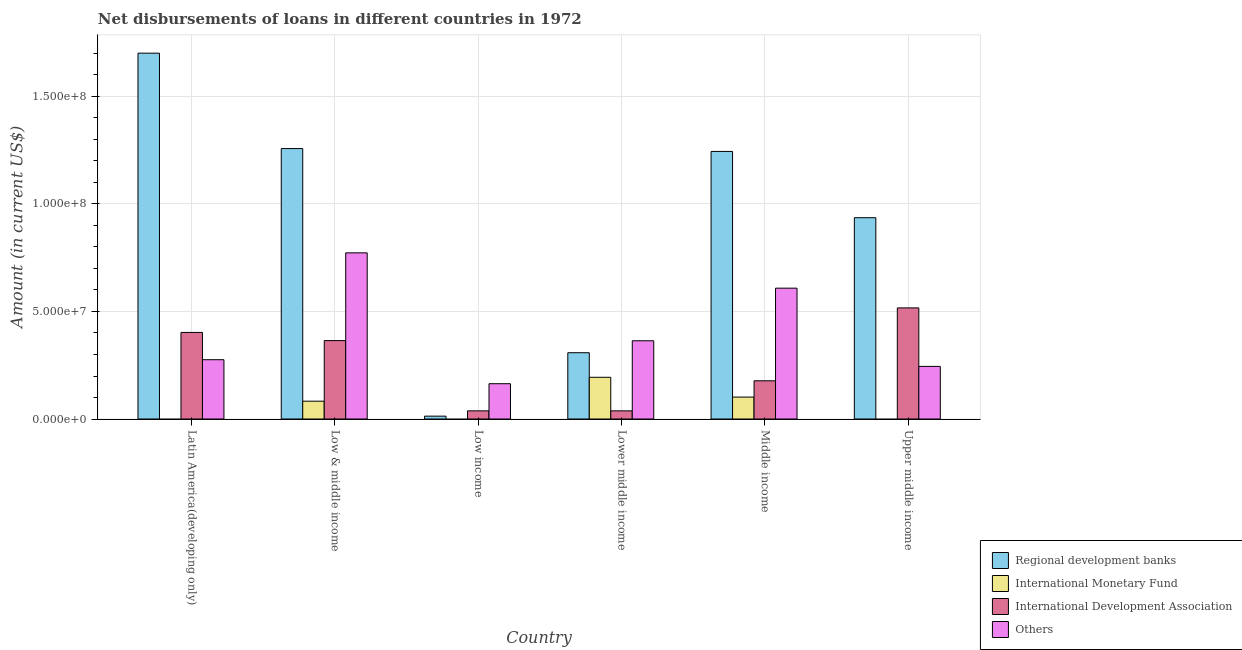How many groups of bars are there?
Provide a short and direct response. 6. Are the number of bars on each tick of the X-axis equal?
Your answer should be very brief. No. How many bars are there on the 6th tick from the left?
Keep it short and to the point. 3. How many bars are there on the 2nd tick from the right?
Provide a succinct answer. 4. What is the label of the 1st group of bars from the left?
Your answer should be compact. Latin America(developing only). In how many cases, is the number of bars for a given country not equal to the number of legend labels?
Make the answer very short. 3. What is the amount of loan disimbursed by regional development banks in Low income?
Provide a short and direct response. 1.33e+06. Across all countries, what is the maximum amount of loan disimbursed by other organisations?
Your answer should be compact. 7.73e+07. Across all countries, what is the minimum amount of loan disimbursed by international development association?
Your answer should be very brief. 3.80e+06. In which country was the amount of loan disimbursed by regional development banks maximum?
Provide a succinct answer. Latin America(developing only). What is the total amount of loan disimbursed by international development association in the graph?
Your answer should be very brief. 1.54e+08. What is the difference between the amount of loan disimbursed by regional development banks in Low & middle income and that in Low income?
Your answer should be compact. 1.24e+08. What is the difference between the amount of loan disimbursed by international monetary fund in Upper middle income and the amount of loan disimbursed by other organisations in Low & middle income?
Give a very brief answer. -7.73e+07. What is the average amount of loan disimbursed by other organisations per country?
Your answer should be very brief. 4.05e+07. What is the difference between the amount of loan disimbursed by international monetary fund and amount of loan disimbursed by regional development banks in Middle income?
Provide a succinct answer. -1.14e+08. Is the amount of loan disimbursed by other organisations in Low & middle income less than that in Middle income?
Your answer should be compact. No. Is the difference between the amount of loan disimbursed by other organisations in Low & middle income and Lower middle income greater than the difference between the amount of loan disimbursed by regional development banks in Low & middle income and Lower middle income?
Ensure brevity in your answer.  No. What is the difference between the highest and the second highest amount of loan disimbursed by regional development banks?
Make the answer very short. 4.44e+07. What is the difference between the highest and the lowest amount of loan disimbursed by other organisations?
Make the answer very short. 6.09e+07. In how many countries, is the amount of loan disimbursed by international monetary fund greater than the average amount of loan disimbursed by international monetary fund taken over all countries?
Provide a short and direct response. 3. Is it the case that in every country, the sum of the amount of loan disimbursed by regional development banks and amount of loan disimbursed by international monetary fund is greater than the amount of loan disimbursed by international development association?
Offer a terse response. No. What is the difference between two consecutive major ticks on the Y-axis?
Provide a short and direct response. 5.00e+07. Are the values on the major ticks of Y-axis written in scientific E-notation?
Provide a succinct answer. Yes. Does the graph contain grids?
Offer a terse response. Yes. Where does the legend appear in the graph?
Offer a very short reply. Bottom right. How many legend labels are there?
Make the answer very short. 4. How are the legend labels stacked?
Give a very brief answer. Vertical. What is the title of the graph?
Offer a terse response. Net disbursements of loans in different countries in 1972. Does "Quality Certification" appear as one of the legend labels in the graph?
Keep it short and to the point. No. What is the label or title of the Y-axis?
Your answer should be very brief. Amount (in current US$). What is the Amount (in current US$) in Regional development banks in Latin America(developing only)?
Offer a very short reply. 1.70e+08. What is the Amount (in current US$) of International Development Association in Latin America(developing only)?
Provide a short and direct response. 4.03e+07. What is the Amount (in current US$) of Others in Latin America(developing only)?
Keep it short and to the point. 2.76e+07. What is the Amount (in current US$) of Regional development banks in Low & middle income?
Ensure brevity in your answer.  1.26e+08. What is the Amount (in current US$) in International Monetary Fund in Low & middle income?
Give a very brief answer. 8.30e+06. What is the Amount (in current US$) of International Development Association in Low & middle income?
Your answer should be very brief. 3.65e+07. What is the Amount (in current US$) of Others in Low & middle income?
Give a very brief answer. 7.73e+07. What is the Amount (in current US$) of Regional development banks in Low income?
Offer a terse response. 1.33e+06. What is the Amount (in current US$) of International Monetary Fund in Low income?
Provide a short and direct response. 0. What is the Amount (in current US$) of International Development Association in Low income?
Provide a succinct answer. 3.80e+06. What is the Amount (in current US$) in Others in Low income?
Provide a short and direct response. 1.64e+07. What is the Amount (in current US$) of Regional development banks in Lower middle income?
Provide a short and direct response. 3.08e+07. What is the Amount (in current US$) of International Monetary Fund in Lower middle income?
Offer a very short reply. 1.94e+07. What is the Amount (in current US$) of International Development Association in Lower middle income?
Offer a terse response. 3.80e+06. What is the Amount (in current US$) of Others in Lower middle income?
Make the answer very short. 3.64e+07. What is the Amount (in current US$) in Regional development banks in Middle income?
Make the answer very short. 1.24e+08. What is the Amount (in current US$) in International Monetary Fund in Middle income?
Offer a terse response. 1.02e+07. What is the Amount (in current US$) of International Development Association in Middle income?
Your answer should be very brief. 1.78e+07. What is the Amount (in current US$) in Others in Middle income?
Provide a short and direct response. 6.09e+07. What is the Amount (in current US$) in Regional development banks in Upper middle income?
Your answer should be very brief. 9.36e+07. What is the Amount (in current US$) of International Monetary Fund in Upper middle income?
Offer a very short reply. 0. What is the Amount (in current US$) of International Development Association in Upper middle income?
Ensure brevity in your answer.  5.17e+07. What is the Amount (in current US$) in Others in Upper middle income?
Your response must be concise. 2.45e+07. Across all countries, what is the maximum Amount (in current US$) of Regional development banks?
Your response must be concise. 1.70e+08. Across all countries, what is the maximum Amount (in current US$) of International Monetary Fund?
Your response must be concise. 1.94e+07. Across all countries, what is the maximum Amount (in current US$) in International Development Association?
Offer a terse response. 5.17e+07. Across all countries, what is the maximum Amount (in current US$) of Others?
Provide a succinct answer. 7.73e+07. Across all countries, what is the minimum Amount (in current US$) in Regional development banks?
Offer a very short reply. 1.33e+06. Across all countries, what is the minimum Amount (in current US$) in International Monetary Fund?
Offer a terse response. 0. Across all countries, what is the minimum Amount (in current US$) of International Development Association?
Offer a terse response. 3.80e+06. Across all countries, what is the minimum Amount (in current US$) of Others?
Ensure brevity in your answer.  1.64e+07. What is the total Amount (in current US$) of Regional development banks in the graph?
Give a very brief answer. 5.46e+08. What is the total Amount (in current US$) of International Monetary Fund in the graph?
Make the answer very short. 3.79e+07. What is the total Amount (in current US$) of International Development Association in the graph?
Offer a terse response. 1.54e+08. What is the total Amount (in current US$) of Others in the graph?
Provide a short and direct response. 2.43e+08. What is the difference between the Amount (in current US$) in Regional development banks in Latin America(developing only) and that in Low & middle income?
Your response must be concise. 4.44e+07. What is the difference between the Amount (in current US$) in International Development Association in Latin America(developing only) and that in Low & middle income?
Offer a terse response. 3.80e+06. What is the difference between the Amount (in current US$) in Others in Latin America(developing only) and that in Low & middle income?
Keep it short and to the point. -4.97e+07. What is the difference between the Amount (in current US$) in Regional development banks in Latin America(developing only) and that in Low income?
Give a very brief answer. 1.69e+08. What is the difference between the Amount (in current US$) of International Development Association in Latin America(developing only) and that in Low income?
Offer a very short reply. 3.65e+07. What is the difference between the Amount (in current US$) of Others in Latin America(developing only) and that in Low income?
Keep it short and to the point. 1.12e+07. What is the difference between the Amount (in current US$) of Regional development banks in Latin America(developing only) and that in Lower middle income?
Your answer should be compact. 1.39e+08. What is the difference between the Amount (in current US$) of International Development Association in Latin America(developing only) and that in Lower middle income?
Provide a short and direct response. 3.65e+07. What is the difference between the Amount (in current US$) in Others in Latin America(developing only) and that in Lower middle income?
Ensure brevity in your answer.  -8.81e+06. What is the difference between the Amount (in current US$) of Regional development banks in Latin America(developing only) and that in Middle income?
Your answer should be compact. 4.57e+07. What is the difference between the Amount (in current US$) in International Development Association in Latin America(developing only) and that in Middle income?
Your answer should be very brief. 2.25e+07. What is the difference between the Amount (in current US$) of Others in Latin America(developing only) and that in Middle income?
Your answer should be very brief. -3.33e+07. What is the difference between the Amount (in current US$) in Regional development banks in Latin America(developing only) and that in Upper middle income?
Make the answer very short. 7.65e+07. What is the difference between the Amount (in current US$) in International Development Association in Latin America(developing only) and that in Upper middle income?
Your response must be concise. -1.14e+07. What is the difference between the Amount (in current US$) in Others in Latin America(developing only) and that in Upper middle income?
Provide a short and direct response. 3.11e+06. What is the difference between the Amount (in current US$) in Regional development banks in Low & middle income and that in Low income?
Your response must be concise. 1.24e+08. What is the difference between the Amount (in current US$) in International Development Association in Low & middle income and that in Low income?
Make the answer very short. 3.27e+07. What is the difference between the Amount (in current US$) of Others in Low & middle income and that in Low income?
Your answer should be compact. 6.09e+07. What is the difference between the Amount (in current US$) of Regional development banks in Low & middle income and that in Lower middle income?
Ensure brevity in your answer.  9.49e+07. What is the difference between the Amount (in current US$) of International Monetary Fund in Low & middle income and that in Lower middle income?
Provide a short and direct response. -1.11e+07. What is the difference between the Amount (in current US$) of International Development Association in Low & middle income and that in Lower middle income?
Offer a terse response. 3.27e+07. What is the difference between the Amount (in current US$) in Others in Low & middle income and that in Lower middle income?
Ensure brevity in your answer.  4.09e+07. What is the difference between the Amount (in current US$) in Regional development banks in Low & middle income and that in Middle income?
Ensure brevity in your answer.  1.33e+06. What is the difference between the Amount (in current US$) of International Monetary Fund in Low & middle income and that in Middle income?
Keep it short and to the point. -1.90e+06. What is the difference between the Amount (in current US$) of International Development Association in Low & middle income and that in Middle income?
Your response must be concise. 1.87e+07. What is the difference between the Amount (in current US$) in Others in Low & middle income and that in Middle income?
Your answer should be very brief. 1.64e+07. What is the difference between the Amount (in current US$) in Regional development banks in Low & middle income and that in Upper middle income?
Provide a succinct answer. 3.22e+07. What is the difference between the Amount (in current US$) in International Development Association in Low & middle income and that in Upper middle income?
Offer a terse response. -1.52e+07. What is the difference between the Amount (in current US$) in Others in Low & middle income and that in Upper middle income?
Make the answer very short. 5.28e+07. What is the difference between the Amount (in current US$) of Regional development banks in Low income and that in Lower middle income?
Your answer should be very brief. -2.95e+07. What is the difference between the Amount (in current US$) in International Development Association in Low income and that in Lower middle income?
Provide a succinct answer. 0. What is the difference between the Amount (in current US$) in Others in Low income and that in Lower middle income?
Ensure brevity in your answer.  -2.00e+07. What is the difference between the Amount (in current US$) in Regional development banks in Low income and that in Middle income?
Keep it short and to the point. -1.23e+08. What is the difference between the Amount (in current US$) of International Development Association in Low income and that in Middle income?
Your answer should be very brief. -1.40e+07. What is the difference between the Amount (in current US$) of Others in Low income and that in Middle income?
Your response must be concise. -4.44e+07. What is the difference between the Amount (in current US$) in Regional development banks in Low income and that in Upper middle income?
Offer a very short reply. -9.23e+07. What is the difference between the Amount (in current US$) of International Development Association in Low income and that in Upper middle income?
Offer a very short reply. -4.79e+07. What is the difference between the Amount (in current US$) of Others in Low income and that in Upper middle income?
Offer a very short reply. -8.05e+06. What is the difference between the Amount (in current US$) of Regional development banks in Lower middle income and that in Middle income?
Provide a succinct answer. -9.36e+07. What is the difference between the Amount (in current US$) of International Monetary Fund in Lower middle income and that in Middle income?
Offer a terse response. 9.21e+06. What is the difference between the Amount (in current US$) of International Development Association in Lower middle income and that in Middle income?
Offer a very short reply. -1.40e+07. What is the difference between the Amount (in current US$) of Others in Lower middle income and that in Middle income?
Keep it short and to the point. -2.45e+07. What is the difference between the Amount (in current US$) of Regional development banks in Lower middle income and that in Upper middle income?
Your response must be concise. -6.28e+07. What is the difference between the Amount (in current US$) in International Development Association in Lower middle income and that in Upper middle income?
Provide a short and direct response. -4.79e+07. What is the difference between the Amount (in current US$) in Others in Lower middle income and that in Upper middle income?
Your answer should be very brief. 1.19e+07. What is the difference between the Amount (in current US$) in Regional development banks in Middle income and that in Upper middle income?
Make the answer very short. 3.08e+07. What is the difference between the Amount (in current US$) of International Development Association in Middle income and that in Upper middle income?
Your answer should be very brief. -3.39e+07. What is the difference between the Amount (in current US$) in Others in Middle income and that in Upper middle income?
Provide a succinct answer. 3.64e+07. What is the difference between the Amount (in current US$) of Regional development banks in Latin America(developing only) and the Amount (in current US$) of International Monetary Fund in Low & middle income?
Keep it short and to the point. 1.62e+08. What is the difference between the Amount (in current US$) in Regional development banks in Latin America(developing only) and the Amount (in current US$) in International Development Association in Low & middle income?
Provide a succinct answer. 1.34e+08. What is the difference between the Amount (in current US$) of Regional development banks in Latin America(developing only) and the Amount (in current US$) of Others in Low & middle income?
Offer a terse response. 9.29e+07. What is the difference between the Amount (in current US$) of International Development Association in Latin America(developing only) and the Amount (in current US$) of Others in Low & middle income?
Give a very brief answer. -3.70e+07. What is the difference between the Amount (in current US$) of Regional development banks in Latin America(developing only) and the Amount (in current US$) of International Development Association in Low income?
Provide a succinct answer. 1.66e+08. What is the difference between the Amount (in current US$) in Regional development banks in Latin America(developing only) and the Amount (in current US$) in Others in Low income?
Ensure brevity in your answer.  1.54e+08. What is the difference between the Amount (in current US$) of International Development Association in Latin America(developing only) and the Amount (in current US$) of Others in Low income?
Your response must be concise. 2.38e+07. What is the difference between the Amount (in current US$) of Regional development banks in Latin America(developing only) and the Amount (in current US$) of International Monetary Fund in Lower middle income?
Provide a short and direct response. 1.51e+08. What is the difference between the Amount (in current US$) in Regional development banks in Latin America(developing only) and the Amount (in current US$) in International Development Association in Lower middle income?
Your response must be concise. 1.66e+08. What is the difference between the Amount (in current US$) in Regional development banks in Latin America(developing only) and the Amount (in current US$) in Others in Lower middle income?
Your response must be concise. 1.34e+08. What is the difference between the Amount (in current US$) of International Development Association in Latin America(developing only) and the Amount (in current US$) of Others in Lower middle income?
Your answer should be compact. 3.88e+06. What is the difference between the Amount (in current US$) in Regional development banks in Latin America(developing only) and the Amount (in current US$) in International Monetary Fund in Middle income?
Your answer should be very brief. 1.60e+08. What is the difference between the Amount (in current US$) in Regional development banks in Latin America(developing only) and the Amount (in current US$) in International Development Association in Middle income?
Your answer should be very brief. 1.52e+08. What is the difference between the Amount (in current US$) of Regional development banks in Latin America(developing only) and the Amount (in current US$) of Others in Middle income?
Provide a short and direct response. 1.09e+08. What is the difference between the Amount (in current US$) of International Development Association in Latin America(developing only) and the Amount (in current US$) of Others in Middle income?
Make the answer very short. -2.06e+07. What is the difference between the Amount (in current US$) in Regional development banks in Latin America(developing only) and the Amount (in current US$) in International Development Association in Upper middle income?
Make the answer very short. 1.18e+08. What is the difference between the Amount (in current US$) of Regional development banks in Latin America(developing only) and the Amount (in current US$) of Others in Upper middle income?
Your response must be concise. 1.46e+08. What is the difference between the Amount (in current US$) of International Development Association in Latin America(developing only) and the Amount (in current US$) of Others in Upper middle income?
Ensure brevity in your answer.  1.58e+07. What is the difference between the Amount (in current US$) of Regional development banks in Low & middle income and the Amount (in current US$) of International Development Association in Low income?
Give a very brief answer. 1.22e+08. What is the difference between the Amount (in current US$) in Regional development banks in Low & middle income and the Amount (in current US$) in Others in Low income?
Ensure brevity in your answer.  1.09e+08. What is the difference between the Amount (in current US$) of International Monetary Fund in Low & middle income and the Amount (in current US$) of International Development Association in Low income?
Make the answer very short. 4.50e+06. What is the difference between the Amount (in current US$) of International Monetary Fund in Low & middle income and the Amount (in current US$) of Others in Low income?
Offer a terse response. -8.12e+06. What is the difference between the Amount (in current US$) in International Development Association in Low & middle income and the Amount (in current US$) in Others in Low income?
Provide a short and direct response. 2.00e+07. What is the difference between the Amount (in current US$) in Regional development banks in Low & middle income and the Amount (in current US$) in International Monetary Fund in Lower middle income?
Provide a short and direct response. 1.06e+08. What is the difference between the Amount (in current US$) in Regional development banks in Low & middle income and the Amount (in current US$) in International Development Association in Lower middle income?
Give a very brief answer. 1.22e+08. What is the difference between the Amount (in current US$) in Regional development banks in Low & middle income and the Amount (in current US$) in Others in Lower middle income?
Your answer should be very brief. 8.94e+07. What is the difference between the Amount (in current US$) of International Monetary Fund in Low & middle income and the Amount (in current US$) of International Development Association in Lower middle income?
Provide a succinct answer. 4.50e+06. What is the difference between the Amount (in current US$) of International Monetary Fund in Low & middle income and the Amount (in current US$) of Others in Lower middle income?
Your answer should be compact. -2.81e+07. What is the difference between the Amount (in current US$) in International Development Association in Low & middle income and the Amount (in current US$) in Others in Lower middle income?
Ensure brevity in your answer.  8.30e+04. What is the difference between the Amount (in current US$) of Regional development banks in Low & middle income and the Amount (in current US$) of International Monetary Fund in Middle income?
Give a very brief answer. 1.16e+08. What is the difference between the Amount (in current US$) of Regional development banks in Low & middle income and the Amount (in current US$) of International Development Association in Middle income?
Your answer should be compact. 1.08e+08. What is the difference between the Amount (in current US$) in Regional development banks in Low & middle income and the Amount (in current US$) in Others in Middle income?
Give a very brief answer. 6.49e+07. What is the difference between the Amount (in current US$) of International Monetary Fund in Low & middle income and the Amount (in current US$) of International Development Association in Middle income?
Give a very brief answer. -9.48e+06. What is the difference between the Amount (in current US$) of International Monetary Fund in Low & middle income and the Amount (in current US$) of Others in Middle income?
Keep it short and to the point. -5.26e+07. What is the difference between the Amount (in current US$) of International Development Association in Low & middle income and the Amount (in current US$) of Others in Middle income?
Make the answer very short. -2.44e+07. What is the difference between the Amount (in current US$) in Regional development banks in Low & middle income and the Amount (in current US$) in International Development Association in Upper middle income?
Offer a very short reply. 7.41e+07. What is the difference between the Amount (in current US$) of Regional development banks in Low & middle income and the Amount (in current US$) of Others in Upper middle income?
Offer a very short reply. 1.01e+08. What is the difference between the Amount (in current US$) in International Monetary Fund in Low & middle income and the Amount (in current US$) in International Development Association in Upper middle income?
Provide a succinct answer. -4.34e+07. What is the difference between the Amount (in current US$) of International Monetary Fund in Low & middle income and the Amount (in current US$) of Others in Upper middle income?
Make the answer very short. -1.62e+07. What is the difference between the Amount (in current US$) of Regional development banks in Low income and the Amount (in current US$) of International Monetary Fund in Lower middle income?
Keep it short and to the point. -1.81e+07. What is the difference between the Amount (in current US$) in Regional development banks in Low income and the Amount (in current US$) in International Development Association in Lower middle income?
Ensure brevity in your answer.  -2.46e+06. What is the difference between the Amount (in current US$) of Regional development banks in Low income and the Amount (in current US$) of Others in Lower middle income?
Ensure brevity in your answer.  -3.51e+07. What is the difference between the Amount (in current US$) in International Development Association in Low income and the Amount (in current US$) in Others in Lower middle income?
Your response must be concise. -3.26e+07. What is the difference between the Amount (in current US$) in Regional development banks in Low income and the Amount (in current US$) in International Monetary Fund in Middle income?
Provide a succinct answer. -8.86e+06. What is the difference between the Amount (in current US$) in Regional development banks in Low income and the Amount (in current US$) in International Development Association in Middle income?
Your answer should be very brief. -1.64e+07. What is the difference between the Amount (in current US$) in Regional development banks in Low income and the Amount (in current US$) in Others in Middle income?
Your answer should be very brief. -5.95e+07. What is the difference between the Amount (in current US$) in International Development Association in Low income and the Amount (in current US$) in Others in Middle income?
Offer a very short reply. -5.71e+07. What is the difference between the Amount (in current US$) in Regional development banks in Low income and the Amount (in current US$) in International Development Association in Upper middle income?
Ensure brevity in your answer.  -5.03e+07. What is the difference between the Amount (in current US$) of Regional development banks in Low income and the Amount (in current US$) of Others in Upper middle income?
Your answer should be compact. -2.31e+07. What is the difference between the Amount (in current US$) of International Development Association in Low income and the Amount (in current US$) of Others in Upper middle income?
Your answer should be very brief. -2.07e+07. What is the difference between the Amount (in current US$) in Regional development banks in Lower middle income and the Amount (in current US$) in International Monetary Fund in Middle income?
Provide a succinct answer. 2.06e+07. What is the difference between the Amount (in current US$) in Regional development banks in Lower middle income and the Amount (in current US$) in International Development Association in Middle income?
Offer a very short reply. 1.30e+07. What is the difference between the Amount (in current US$) of Regional development banks in Lower middle income and the Amount (in current US$) of Others in Middle income?
Provide a succinct answer. -3.00e+07. What is the difference between the Amount (in current US$) of International Monetary Fund in Lower middle income and the Amount (in current US$) of International Development Association in Middle income?
Your answer should be compact. 1.63e+06. What is the difference between the Amount (in current US$) of International Monetary Fund in Lower middle income and the Amount (in current US$) of Others in Middle income?
Make the answer very short. -4.14e+07. What is the difference between the Amount (in current US$) of International Development Association in Lower middle income and the Amount (in current US$) of Others in Middle income?
Ensure brevity in your answer.  -5.71e+07. What is the difference between the Amount (in current US$) of Regional development banks in Lower middle income and the Amount (in current US$) of International Development Association in Upper middle income?
Offer a very short reply. -2.09e+07. What is the difference between the Amount (in current US$) of Regional development banks in Lower middle income and the Amount (in current US$) of Others in Upper middle income?
Offer a very short reply. 6.36e+06. What is the difference between the Amount (in current US$) in International Monetary Fund in Lower middle income and the Amount (in current US$) in International Development Association in Upper middle income?
Your response must be concise. -3.23e+07. What is the difference between the Amount (in current US$) of International Monetary Fund in Lower middle income and the Amount (in current US$) of Others in Upper middle income?
Provide a succinct answer. -5.06e+06. What is the difference between the Amount (in current US$) in International Development Association in Lower middle income and the Amount (in current US$) in Others in Upper middle income?
Your response must be concise. -2.07e+07. What is the difference between the Amount (in current US$) of Regional development banks in Middle income and the Amount (in current US$) of International Development Association in Upper middle income?
Give a very brief answer. 7.28e+07. What is the difference between the Amount (in current US$) of Regional development banks in Middle income and the Amount (in current US$) of Others in Upper middle income?
Provide a short and direct response. 1.00e+08. What is the difference between the Amount (in current US$) in International Monetary Fund in Middle income and the Amount (in current US$) in International Development Association in Upper middle income?
Offer a very short reply. -4.15e+07. What is the difference between the Amount (in current US$) in International Monetary Fund in Middle income and the Amount (in current US$) in Others in Upper middle income?
Make the answer very short. -1.43e+07. What is the difference between the Amount (in current US$) in International Development Association in Middle income and the Amount (in current US$) in Others in Upper middle income?
Keep it short and to the point. -6.69e+06. What is the average Amount (in current US$) of Regional development banks per country?
Give a very brief answer. 9.10e+07. What is the average Amount (in current US$) in International Monetary Fund per country?
Offer a very short reply. 6.32e+06. What is the average Amount (in current US$) of International Development Association per country?
Make the answer very short. 2.56e+07. What is the average Amount (in current US$) of Others per country?
Provide a short and direct response. 4.05e+07. What is the difference between the Amount (in current US$) in Regional development banks and Amount (in current US$) in International Development Association in Latin America(developing only)?
Offer a terse response. 1.30e+08. What is the difference between the Amount (in current US$) of Regional development banks and Amount (in current US$) of Others in Latin America(developing only)?
Offer a terse response. 1.43e+08. What is the difference between the Amount (in current US$) of International Development Association and Amount (in current US$) of Others in Latin America(developing only)?
Your answer should be very brief. 1.27e+07. What is the difference between the Amount (in current US$) in Regional development banks and Amount (in current US$) in International Monetary Fund in Low & middle income?
Give a very brief answer. 1.17e+08. What is the difference between the Amount (in current US$) of Regional development banks and Amount (in current US$) of International Development Association in Low & middle income?
Keep it short and to the point. 8.93e+07. What is the difference between the Amount (in current US$) of Regional development banks and Amount (in current US$) of Others in Low & middle income?
Your answer should be compact. 4.85e+07. What is the difference between the Amount (in current US$) of International Monetary Fund and Amount (in current US$) of International Development Association in Low & middle income?
Your answer should be very brief. -2.82e+07. What is the difference between the Amount (in current US$) in International Monetary Fund and Amount (in current US$) in Others in Low & middle income?
Provide a succinct answer. -6.90e+07. What is the difference between the Amount (in current US$) in International Development Association and Amount (in current US$) in Others in Low & middle income?
Your answer should be very brief. -4.08e+07. What is the difference between the Amount (in current US$) of Regional development banks and Amount (in current US$) of International Development Association in Low income?
Make the answer very short. -2.46e+06. What is the difference between the Amount (in current US$) of Regional development banks and Amount (in current US$) of Others in Low income?
Ensure brevity in your answer.  -1.51e+07. What is the difference between the Amount (in current US$) in International Development Association and Amount (in current US$) in Others in Low income?
Make the answer very short. -1.26e+07. What is the difference between the Amount (in current US$) in Regional development banks and Amount (in current US$) in International Monetary Fund in Lower middle income?
Provide a short and direct response. 1.14e+07. What is the difference between the Amount (in current US$) of Regional development banks and Amount (in current US$) of International Development Association in Lower middle income?
Provide a short and direct response. 2.70e+07. What is the difference between the Amount (in current US$) of Regional development banks and Amount (in current US$) of Others in Lower middle income?
Make the answer very short. -5.56e+06. What is the difference between the Amount (in current US$) in International Monetary Fund and Amount (in current US$) in International Development Association in Lower middle income?
Provide a short and direct response. 1.56e+07. What is the difference between the Amount (in current US$) of International Monetary Fund and Amount (in current US$) of Others in Lower middle income?
Your answer should be compact. -1.70e+07. What is the difference between the Amount (in current US$) of International Development Association and Amount (in current US$) of Others in Lower middle income?
Your answer should be compact. -3.26e+07. What is the difference between the Amount (in current US$) in Regional development banks and Amount (in current US$) in International Monetary Fund in Middle income?
Provide a succinct answer. 1.14e+08. What is the difference between the Amount (in current US$) in Regional development banks and Amount (in current US$) in International Development Association in Middle income?
Provide a succinct answer. 1.07e+08. What is the difference between the Amount (in current US$) of Regional development banks and Amount (in current US$) of Others in Middle income?
Keep it short and to the point. 6.36e+07. What is the difference between the Amount (in current US$) of International Monetary Fund and Amount (in current US$) of International Development Association in Middle income?
Your response must be concise. -7.58e+06. What is the difference between the Amount (in current US$) of International Monetary Fund and Amount (in current US$) of Others in Middle income?
Ensure brevity in your answer.  -5.07e+07. What is the difference between the Amount (in current US$) in International Development Association and Amount (in current US$) in Others in Middle income?
Your answer should be compact. -4.31e+07. What is the difference between the Amount (in current US$) of Regional development banks and Amount (in current US$) of International Development Association in Upper middle income?
Provide a short and direct response. 4.19e+07. What is the difference between the Amount (in current US$) of Regional development banks and Amount (in current US$) of Others in Upper middle income?
Offer a terse response. 6.91e+07. What is the difference between the Amount (in current US$) in International Development Association and Amount (in current US$) in Others in Upper middle income?
Provide a short and direct response. 2.72e+07. What is the ratio of the Amount (in current US$) in Regional development banks in Latin America(developing only) to that in Low & middle income?
Give a very brief answer. 1.35. What is the ratio of the Amount (in current US$) in International Development Association in Latin America(developing only) to that in Low & middle income?
Keep it short and to the point. 1.1. What is the ratio of the Amount (in current US$) in Others in Latin America(developing only) to that in Low & middle income?
Make the answer very short. 0.36. What is the ratio of the Amount (in current US$) of Regional development banks in Latin America(developing only) to that in Low income?
Ensure brevity in your answer.  127.63. What is the ratio of the Amount (in current US$) of International Development Association in Latin America(developing only) to that in Low income?
Your answer should be very brief. 10.61. What is the ratio of the Amount (in current US$) in Others in Latin America(developing only) to that in Low income?
Offer a very short reply. 1.68. What is the ratio of the Amount (in current US$) in Regional development banks in Latin America(developing only) to that in Lower middle income?
Ensure brevity in your answer.  5.52. What is the ratio of the Amount (in current US$) of International Development Association in Latin America(developing only) to that in Lower middle income?
Provide a short and direct response. 10.61. What is the ratio of the Amount (in current US$) in Others in Latin America(developing only) to that in Lower middle income?
Offer a terse response. 0.76. What is the ratio of the Amount (in current US$) of Regional development banks in Latin America(developing only) to that in Middle income?
Provide a short and direct response. 1.37. What is the ratio of the Amount (in current US$) in International Development Association in Latin America(developing only) to that in Middle income?
Give a very brief answer. 2.27. What is the ratio of the Amount (in current US$) of Others in Latin America(developing only) to that in Middle income?
Make the answer very short. 0.45. What is the ratio of the Amount (in current US$) of Regional development banks in Latin America(developing only) to that in Upper middle income?
Your answer should be very brief. 1.82. What is the ratio of the Amount (in current US$) of International Development Association in Latin America(developing only) to that in Upper middle income?
Your answer should be compact. 0.78. What is the ratio of the Amount (in current US$) of Others in Latin America(developing only) to that in Upper middle income?
Provide a succinct answer. 1.13. What is the ratio of the Amount (in current US$) in Regional development banks in Low & middle income to that in Low income?
Make the answer very short. 94.35. What is the ratio of the Amount (in current US$) in International Development Association in Low & middle income to that in Low income?
Give a very brief answer. 9.61. What is the ratio of the Amount (in current US$) of Others in Low & middle income to that in Low income?
Your response must be concise. 4.71. What is the ratio of the Amount (in current US$) in Regional development banks in Low & middle income to that in Lower middle income?
Your answer should be very brief. 4.08. What is the ratio of the Amount (in current US$) of International Monetary Fund in Low & middle income to that in Lower middle income?
Offer a terse response. 0.43. What is the ratio of the Amount (in current US$) of International Development Association in Low & middle income to that in Lower middle income?
Your answer should be compact. 9.61. What is the ratio of the Amount (in current US$) of Others in Low & middle income to that in Lower middle income?
Ensure brevity in your answer.  2.12. What is the ratio of the Amount (in current US$) in Regional development banks in Low & middle income to that in Middle income?
Make the answer very short. 1.01. What is the ratio of the Amount (in current US$) of International Monetary Fund in Low & middle income to that in Middle income?
Provide a short and direct response. 0.81. What is the ratio of the Amount (in current US$) of International Development Association in Low & middle income to that in Middle income?
Make the answer very short. 2.05. What is the ratio of the Amount (in current US$) of Others in Low & middle income to that in Middle income?
Provide a short and direct response. 1.27. What is the ratio of the Amount (in current US$) of Regional development banks in Low & middle income to that in Upper middle income?
Offer a terse response. 1.34. What is the ratio of the Amount (in current US$) in International Development Association in Low & middle income to that in Upper middle income?
Offer a terse response. 0.71. What is the ratio of the Amount (in current US$) in Others in Low & middle income to that in Upper middle income?
Offer a very short reply. 3.16. What is the ratio of the Amount (in current US$) in Regional development banks in Low income to that in Lower middle income?
Ensure brevity in your answer.  0.04. What is the ratio of the Amount (in current US$) in Others in Low income to that in Lower middle income?
Give a very brief answer. 0.45. What is the ratio of the Amount (in current US$) of Regional development banks in Low income to that in Middle income?
Ensure brevity in your answer.  0.01. What is the ratio of the Amount (in current US$) in International Development Association in Low income to that in Middle income?
Offer a very short reply. 0.21. What is the ratio of the Amount (in current US$) in Others in Low income to that in Middle income?
Your response must be concise. 0.27. What is the ratio of the Amount (in current US$) in Regional development banks in Low income to that in Upper middle income?
Your answer should be very brief. 0.01. What is the ratio of the Amount (in current US$) in International Development Association in Low income to that in Upper middle income?
Give a very brief answer. 0.07. What is the ratio of the Amount (in current US$) in Others in Low income to that in Upper middle income?
Your answer should be very brief. 0.67. What is the ratio of the Amount (in current US$) of Regional development banks in Lower middle income to that in Middle income?
Offer a very short reply. 0.25. What is the ratio of the Amount (in current US$) in International Monetary Fund in Lower middle income to that in Middle income?
Ensure brevity in your answer.  1.9. What is the ratio of the Amount (in current US$) in International Development Association in Lower middle income to that in Middle income?
Your answer should be compact. 0.21. What is the ratio of the Amount (in current US$) of Others in Lower middle income to that in Middle income?
Offer a terse response. 0.6. What is the ratio of the Amount (in current US$) of Regional development banks in Lower middle income to that in Upper middle income?
Offer a terse response. 0.33. What is the ratio of the Amount (in current US$) of International Development Association in Lower middle income to that in Upper middle income?
Keep it short and to the point. 0.07. What is the ratio of the Amount (in current US$) of Others in Lower middle income to that in Upper middle income?
Give a very brief answer. 1.49. What is the ratio of the Amount (in current US$) of Regional development banks in Middle income to that in Upper middle income?
Ensure brevity in your answer.  1.33. What is the ratio of the Amount (in current US$) of International Development Association in Middle income to that in Upper middle income?
Offer a very short reply. 0.34. What is the ratio of the Amount (in current US$) of Others in Middle income to that in Upper middle income?
Make the answer very short. 2.49. What is the difference between the highest and the second highest Amount (in current US$) of Regional development banks?
Make the answer very short. 4.44e+07. What is the difference between the highest and the second highest Amount (in current US$) of International Monetary Fund?
Offer a very short reply. 9.21e+06. What is the difference between the highest and the second highest Amount (in current US$) in International Development Association?
Your answer should be compact. 1.14e+07. What is the difference between the highest and the second highest Amount (in current US$) in Others?
Keep it short and to the point. 1.64e+07. What is the difference between the highest and the lowest Amount (in current US$) in Regional development banks?
Your response must be concise. 1.69e+08. What is the difference between the highest and the lowest Amount (in current US$) in International Monetary Fund?
Offer a terse response. 1.94e+07. What is the difference between the highest and the lowest Amount (in current US$) in International Development Association?
Offer a terse response. 4.79e+07. What is the difference between the highest and the lowest Amount (in current US$) of Others?
Offer a very short reply. 6.09e+07. 